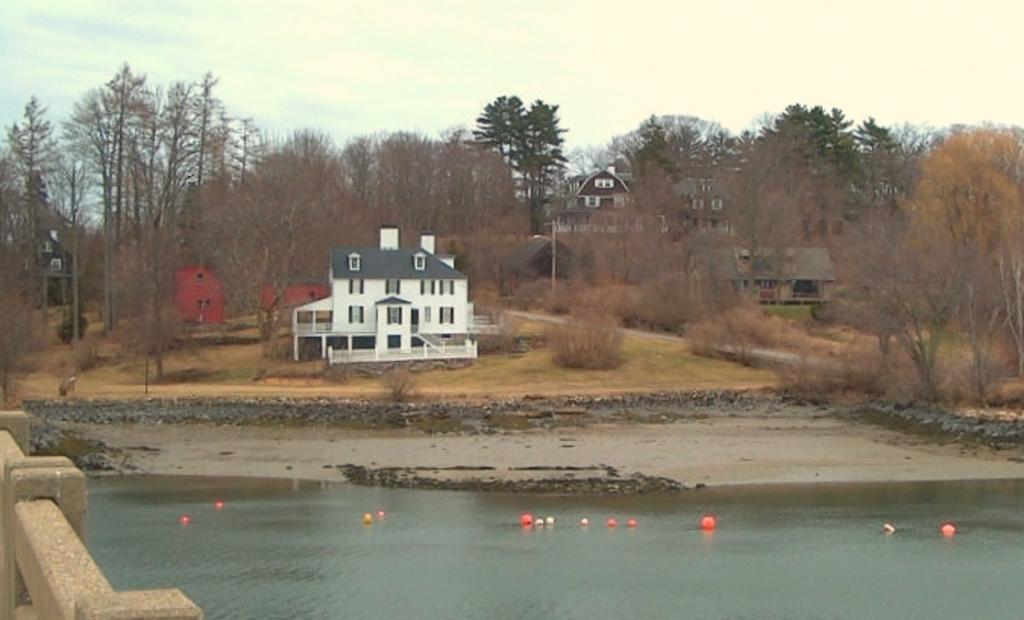Could you give a brief overview of what you see in this image? In this image there is a small lake with some balls on it, beside that there are so many trees and buildings. 